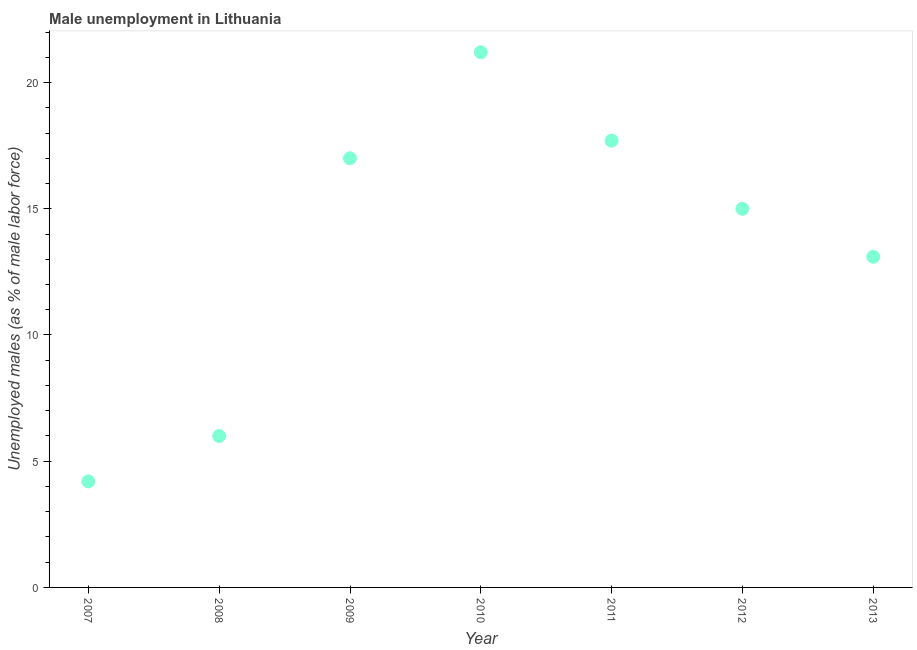Across all years, what is the maximum unemployed males population?
Offer a terse response. 21.2. Across all years, what is the minimum unemployed males population?
Ensure brevity in your answer.  4.2. In which year was the unemployed males population minimum?
Make the answer very short. 2007. What is the sum of the unemployed males population?
Provide a succinct answer. 94.2. What is the difference between the unemployed males population in 2007 and 2013?
Make the answer very short. -8.9. What is the average unemployed males population per year?
Provide a short and direct response. 13.46. What is the median unemployed males population?
Provide a succinct answer. 15. Do a majority of the years between 2011 and 2008 (inclusive) have unemployed males population greater than 18 %?
Offer a very short reply. Yes. What is the ratio of the unemployed males population in 2008 to that in 2013?
Your response must be concise. 0.46. Is the unemployed males population in 2008 less than that in 2013?
Your response must be concise. Yes. Is the difference between the unemployed males population in 2010 and 2012 greater than the difference between any two years?
Make the answer very short. No. Is the sum of the unemployed males population in 2008 and 2010 greater than the maximum unemployed males population across all years?
Offer a terse response. Yes. What is the difference between the highest and the lowest unemployed males population?
Offer a very short reply. 17. In how many years, is the unemployed males population greater than the average unemployed males population taken over all years?
Your answer should be very brief. 4. Does the unemployed males population monotonically increase over the years?
Offer a terse response. No. How many years are there in the graph?
Your answer should be very brief. 7. Does the graph contain grids?
Your answer should be very brief. No. What is the title of the graph?
Offer a very short reply. Male unemployment in Lithuania. What is the label or title of the Y-axis?
Your response must be concise. Unemployed males (as % of male labor force). What is the Unemployed males (as % of male labor force) in 2007?
Offer a very short reply. 4.2. What is the Unemployed males (as % of male labor force) in 2010?
Provide a short and direct response. 21.2. What is the Unemployed males (as % of male labor force) in 2011?
Offer a terse response. 17.7. What is the Unemployed males (as % of male labor force) in 2012?
Your answer should be very brief. 15. What is the Unemployed males (as % of male labor force) in 2013?
Offer a terse response. 13.1. What is the difference between the Unemployed males (as % of male labor force) in 2007 and 2008?
Your response must be concise. -1.8. What is the difference between the Unemployed males (as % of male labor force) in 2007 and 2010?
Give a very brief answer. -17. What is the difference between the Unemployed males (as % of male labor force) in 2007 and 2012?
Provide a succinct answer. -10.8. What is the difference between the Unemployed males (as % of male labor force) in 2007 and 2013?
Ensure brevity in your answer.  -8.9. What is the difference between the Unemployed males (as % of male labor force) in 2008 and 2009?
Offer a terse response. -11. What is the difference between the Unemployed males (as % of male labor force) in 2008 and 2010?
Provide a succinct answer. -15.2. What is the difference between the Unemployed males (as % of male labor force) in 2008 and 2011?
Provide a short and direct response. -11.7. What is the difference between the Unemployed males (as % of male labor force) in 2008 and 2012?
Your answer should be compact. -9. What is the difference between the Unemployed males (as % of male labor force) in 2008 and 2013?
Give a very brief answer. -7.1. What is the difference between the Unemployed males (as % of male labor force) in 2009 and 2011?
Your answer should be compact. -0.7. What is the difference between the Unemployed males (as % of male labor force) in 2009 and 2012?
Give a very brief answer. 2. What is the difference between the Unemployed males (as % of male labor force) in 2009 and 2013?
Provide a succinct answer. 3.9. What is the difference between the Unemployed males (as % of male labor force) in 2011 and 2012?
Keep it short and to the point. 2.7. What is the difference between the Unemployed males (as % of male labor force) in 2011 and 2013?
Your answer should be compact. 4.6. What is the ratio of the Unemployed males (as % of male labor force) in 2007 to that in 2008?
Your response must be concise. 0.7. What is the ratio of the Unemployed males (as % of male labor force) in 2007 to that in 2009?
Provide a short and direct response. 0.25. What is the ratio of the Unemployed males (as % of male labor force) in 2007 to that in 2010?
Provide a succinct answer. 0.2. What is the ratio of the Unemployed males (as % of male labor force) in 2007 to that in 2011?
Offer a terse response. 0.24. What is the ratio of the Unemployed males (as % of male labor force) in 2007 to that in 2012?
Your answer should be very brief. 0.28. What is the ratio of the Unemployed males (as % of male labor force) in 2007 to that in 2013?
Provide a succinct answer. 0.32. What is the ratio of the Unemployed males (as % of male labor force) in 2008 to that in 2009?
Ensure brevity in your answer.  0.35. What is the ratio of the Unemployed males (as % of male labor force) in 2008 to that in 2010?
Your response must be concise. 0.28. What is the ratio of the Unemployed males (as % of male labor force) in 2008 to that in 2011?
Make the answer very short. 0.34. What is the ratio of the Unemployed males (as % of male labor force) in 2008 to that in 2012?
Keep it short and to the point. 0.4. What is the ratio of the Unemployed males (as % of male labor force) in 2008 to that in 2013?
Provide a short and direct response. 0.46. What is the ratio of the Unemployed males (as % of male labor force) in 2009 to that in 2010?
Your response must be concise. 0.8. What is the ratio of the Unemployed males (as % of male labor force) in 2009 to that in 2011?
Provide a short and direct response. 0.96. What is the ratio of the Unemployed males (as % of male labor force) in 2009 to that in 2012?
Give a very brief answer. 1.13. What is the ratio of the Unemployed males (as % of male labor force) in 2009 to that in 2013?
Keep it short and to the point. 1.3. What is the ratio of the Unemployed males (as % of male labor force) in 2010 to that in 2011?
Offer a very short reply. 1.2. What is the ratio of the Unemployed males (as % of male labor force) in 2010 to that in 2012?
Offer a terse response. 1.41. What is the ratio of the Unemployed males (as % of male labor force) in 2010 to that in 2013?
Offer a very short reply. 1.62. What is the ratio of the Unemployed males (as % of male labor force) in 2011 to that in 2012?
Offer a very short reply. 1.18. What is the ratio of the Unemployed males (as % of male labor force) in 2011 to that in 2013?
Ensure brevity in your answer.  1.35. What is the ratio of the Unemployed males (as % of male labor force) in 2012 to that in 2013?
Give a very brief answer. 1.15. 